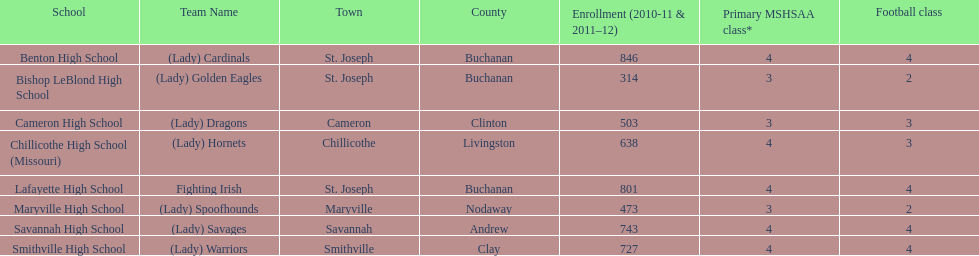Which school has the least amount of student enrollment between 2010-2011 and 2011-2012? Bishop LeBlond High School. 